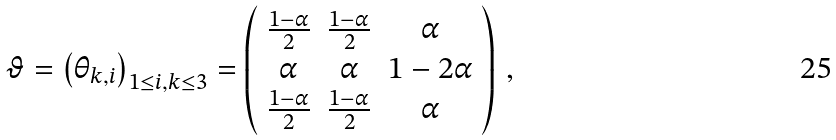Convert formula to latex. <formula><loc_0><loc_0><loc_500><loc_500>\vartheta = \left ( \theta _ { k , i } \right ) _ { 1 \leq i , k \leq 3 } = \left ( \begin{array} { c c c } \frac { 1 - \alpha } { 2 } & \frac { 1 - \alpha } { 2 } & \alpha \\ \alpha & \alpha & 1 - 2 \alpha \\ \frac { 1 - \alpha } { 2 } & \frac { 1 - \alpha } { 2 } & \alpha \\ \end{array} \right ) \, ,</formula> 